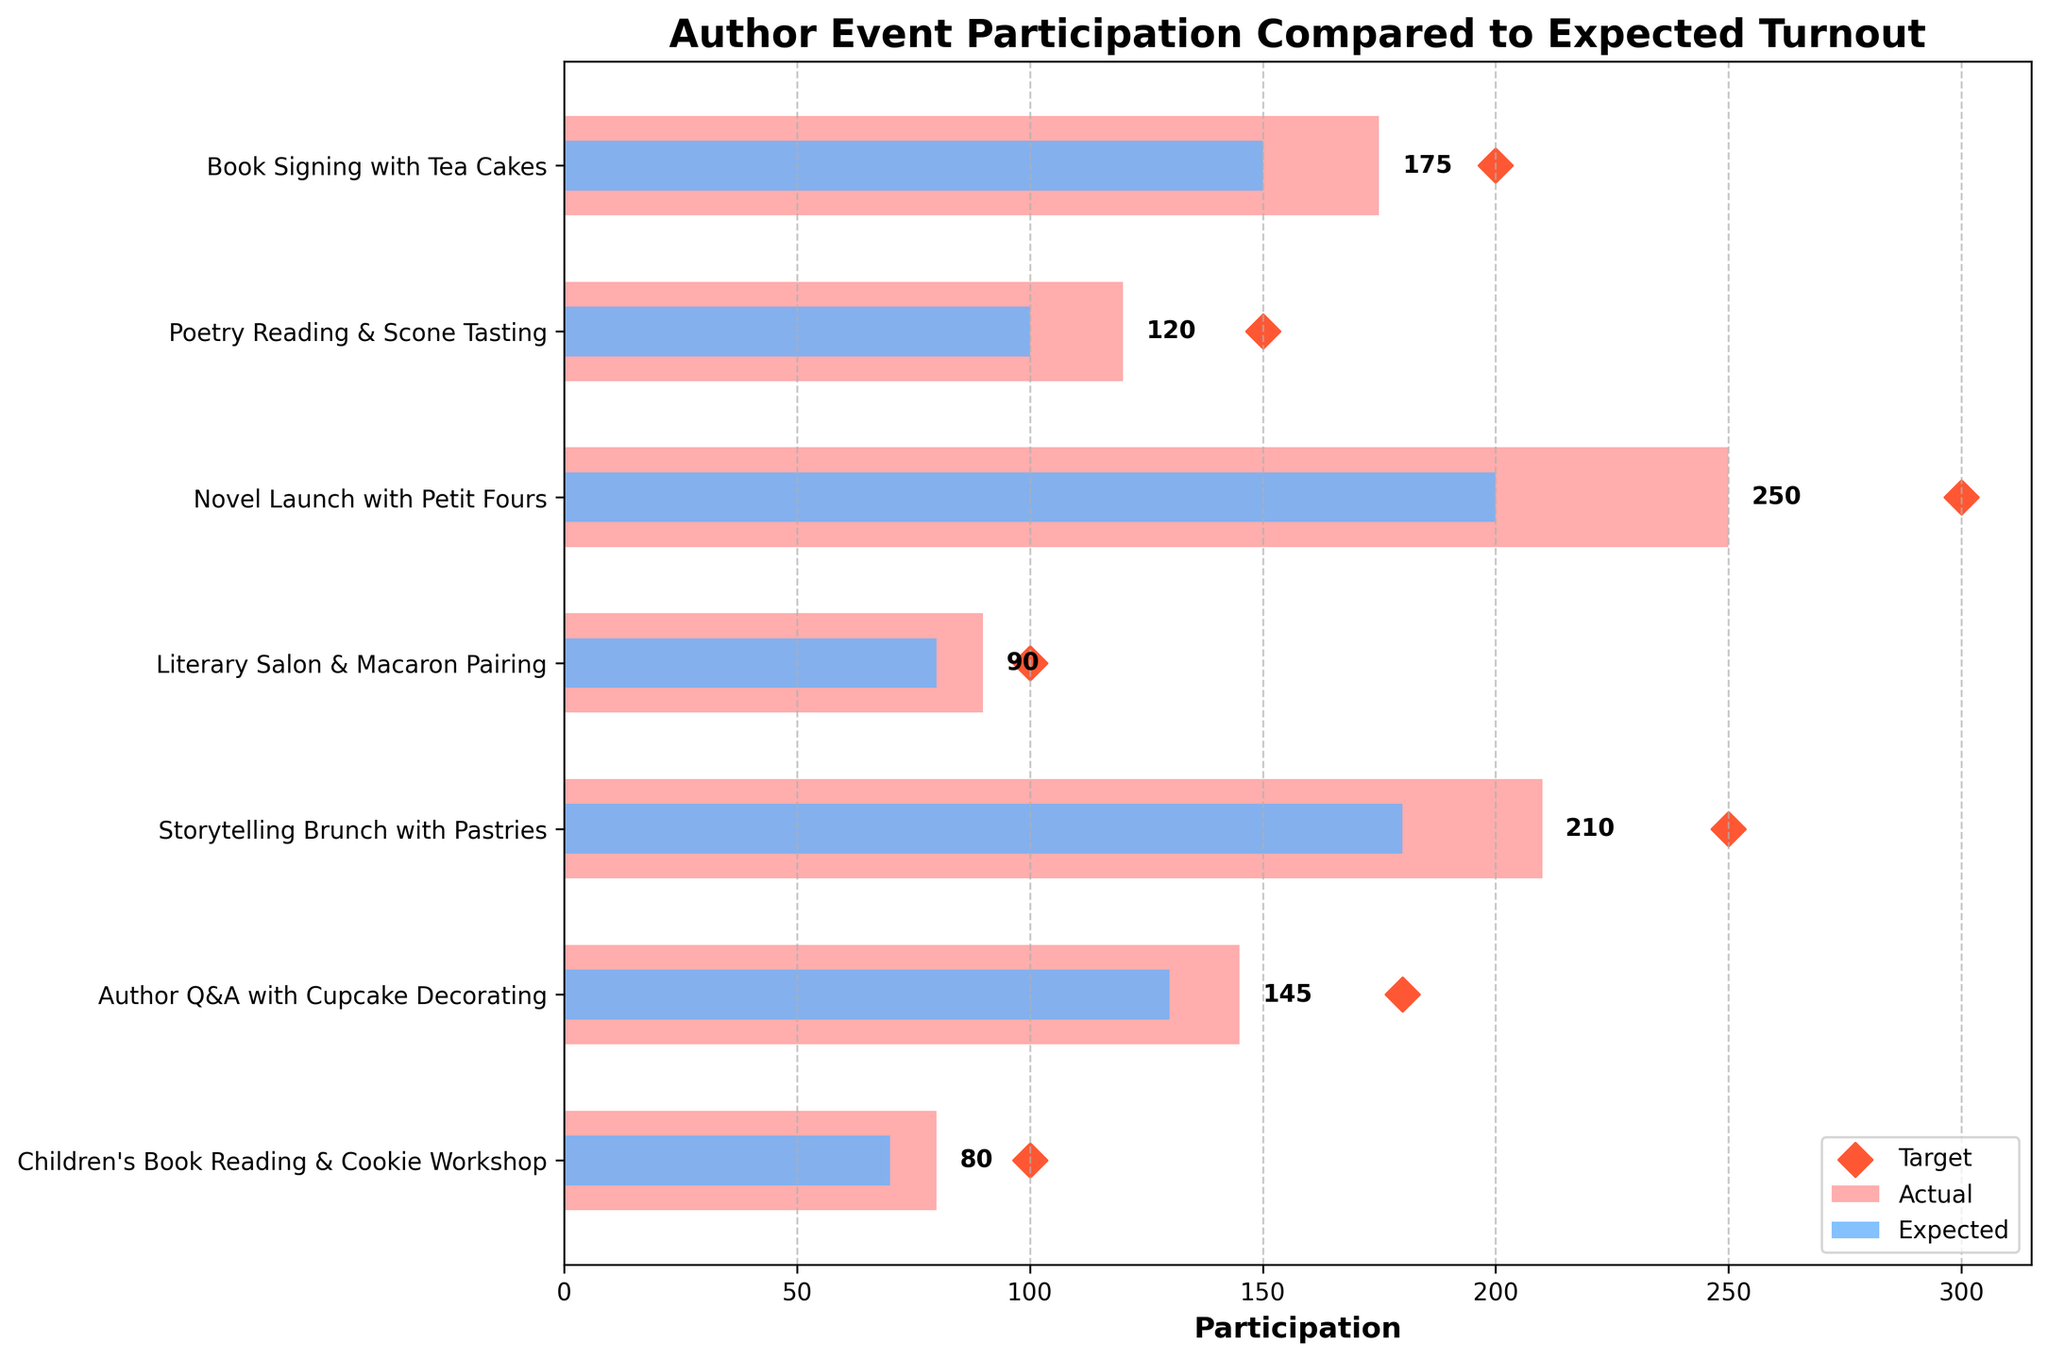Which event had the highest actual participation? The event with the highest actual participation can be identified by looking at the longest bar in the Actual Participation bar chart.
Answer: Novel Launch with Petit Fours What is the title of the chart? The title of the chart is displayed at the top-centre of the figure.
Answer: Author Event Participation Compared to Expected Turnout How does the actual participation for "Poetry Reading & Scone Tasting" compare to its expected turnout? By comparing the lengths of the bars for "Poetry Reading & Scone Tasting", the actual (120) is higher than the expected turnout (100).
Answer: Higher Which event was closest to meeting its target participation? By looking at the scatter plots indicating targets and comparing their proximity to the actual participation bars, "Literary Salon & Macaron Pairing" came closest to its target (90 actual vs. 100 target).
Answer: Literary Salon & Macaron Pairing On average, how much higher or lower is the actual participation compared to the expected turnout across all events? Calculate the total difference of actual minus expected for each event and then find the average difference: (175-150 + 120-100 + 250-200 + 90-80 + 210-180 + 145-130 + 80-70) / 7 = (25 + 20 + 50 + 10 + 30 + 15 + 10) / 7 = 160 / 7.
Answer: Approximately 22.86 higher How many events had an actual participation that exceeded their expected turnout? Count the number of events where the actual participation bar is longer than the expected turnout bar: 7 out of 7 events have higher actual participation.
Answer: 7 Which event had the lowest deviation from its target? The event with the lowest difference between actual participation and target can be found by calculating the deviation for each event and identifying the smallest value: "Literary Salon & Macaron Pairing" (100 target - 90 actual = 10).
Answer: Literary Salon & Macaron Pairing Which event type had the closest actual participation to the expected turnout? Compare the lengths of the actual and expected participation bars for each event, and find the event with the smallest gap: "Children's Book Reading & Cookie Workshop" (80 actual vs. 70 expected, difference of 10).
Answer: Children's Book Reading & Cookie Workshop What is the Axes label for the horizontal bars? The label for the horizontal axis, which indicates the measure of participation, is placed along the length of the X-axis.
Answer: Participation 